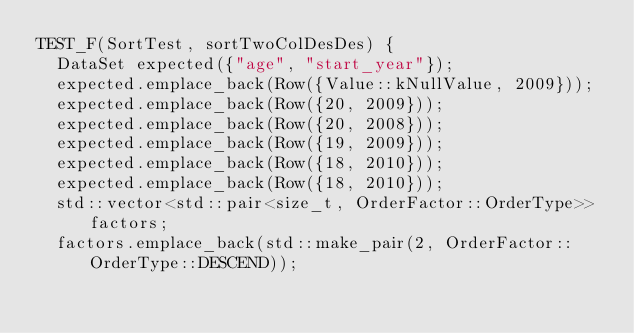Convert code to text. <code><loc_0><loc_0><loc_500><loc_500><_C++_>TEST_F(SortTest, sortTwoColDesDes) {
  DataSet expected({"age", "start_year"});
  expected.emplace_back(Row({Value::kNullValue, 2009}));
  expected.emplace_back(Row({20, 2009}));
  expected.emplace_back(Row({20, 2008}));
  expected.emplace_back(Row({19, 2009}));
  expected.emplace_back(Row({18, 2010}));
  expected.emplace_back(Row({18, 2010}));
  std::vector<std::pair<size_t, OrderFactor::OrderType>> factors;
  factors.emplace_back(std::make_pair(2, OrderFactor::OrderType::DESCEND));</code> 